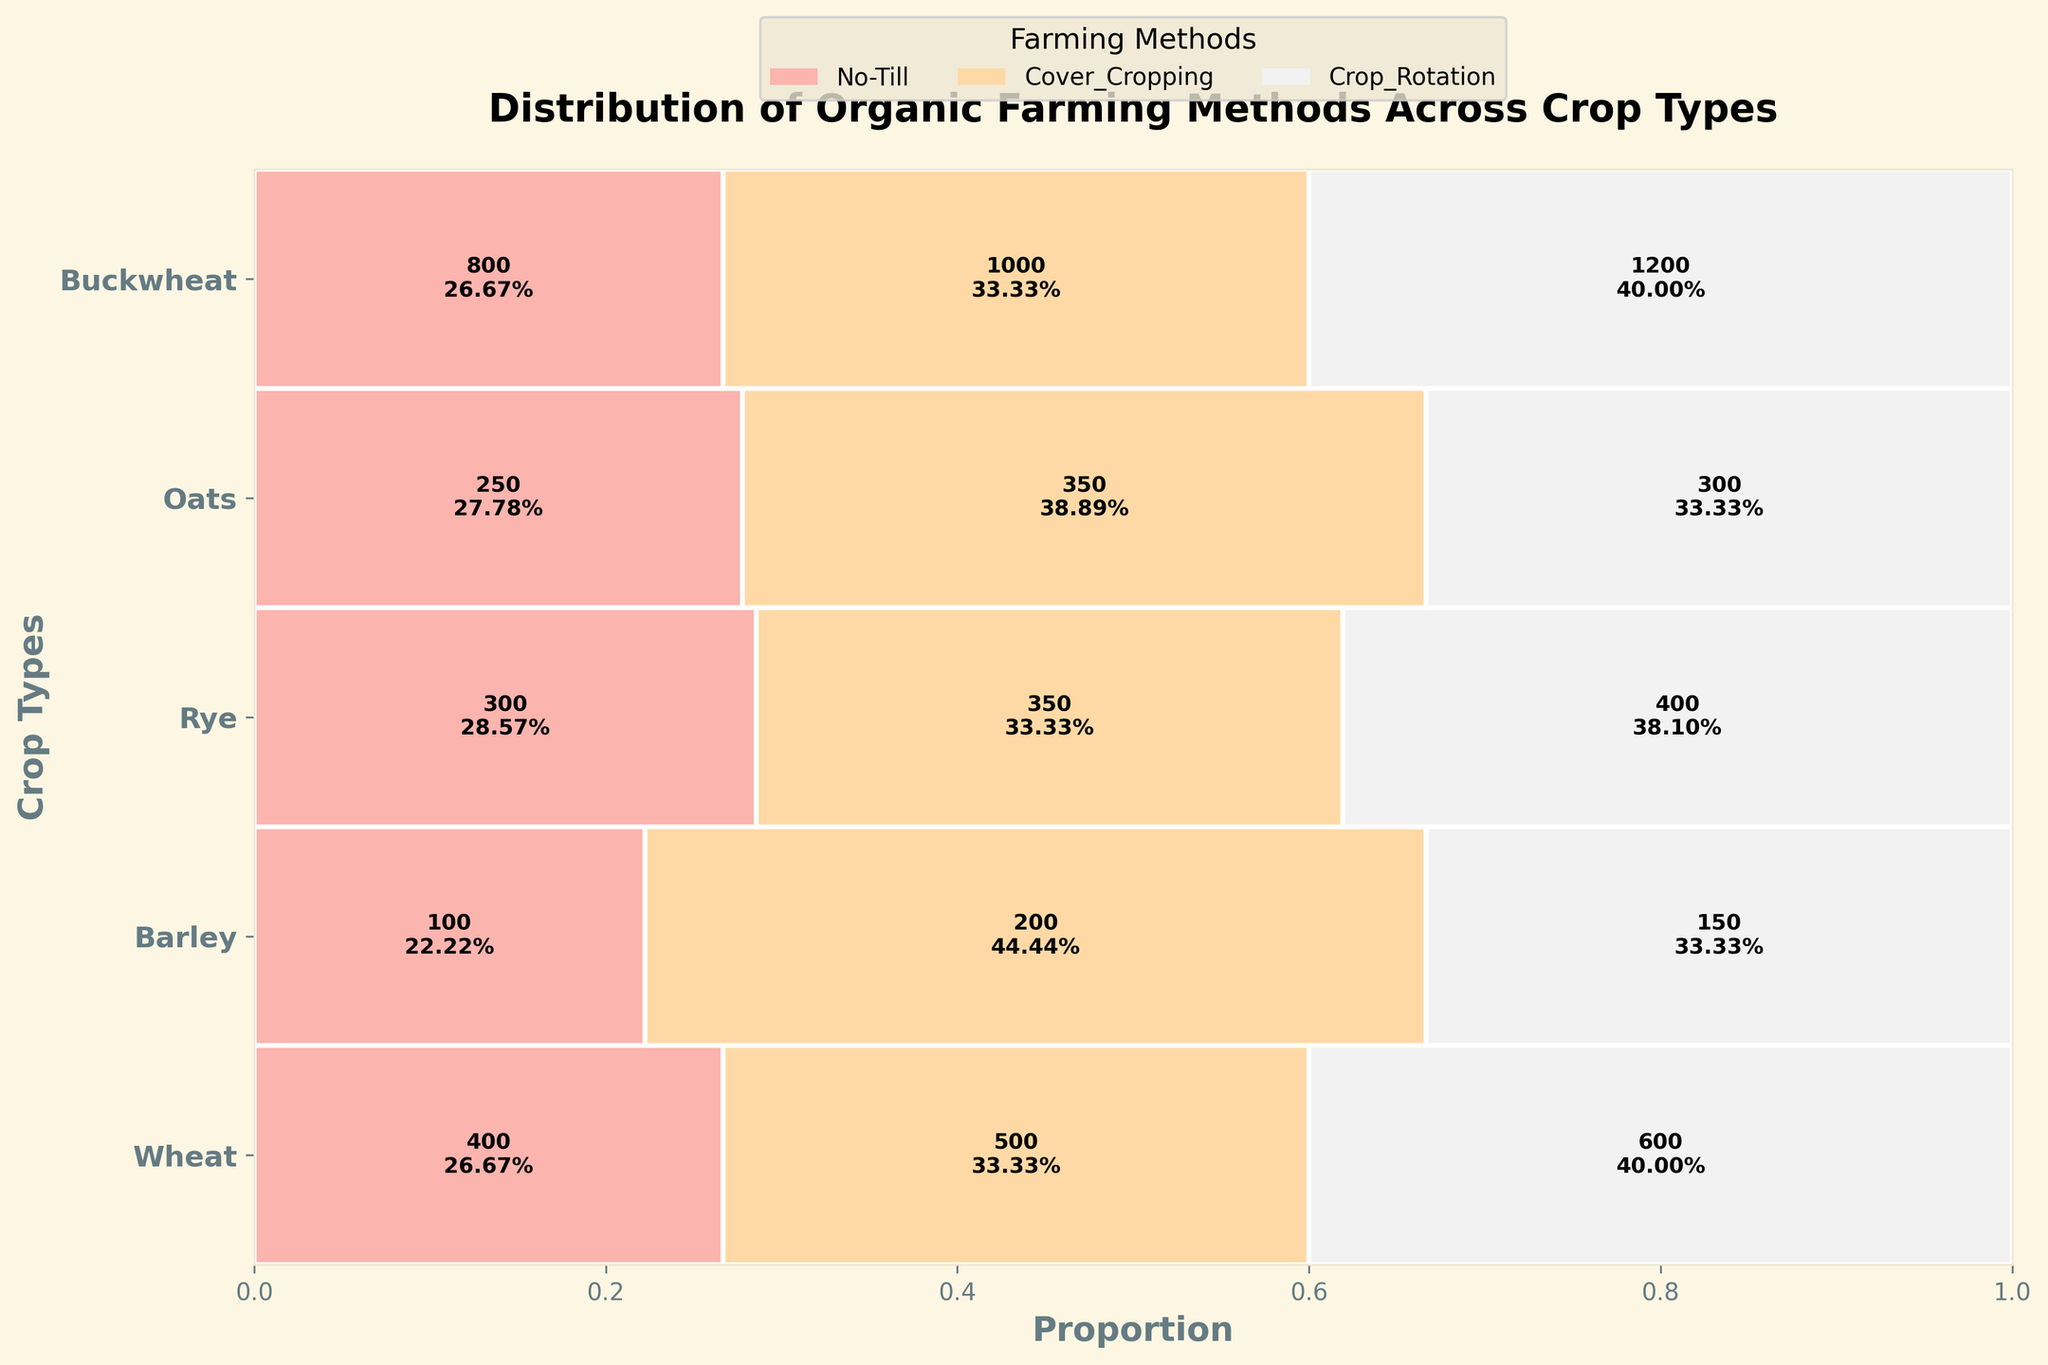What is the title of the plot? The title is located at the top of the plot, it typically describes the content or purpose of the plot.
Answer: Distribution of Organic Farming Methods Across Crop Types Which farming method has the largest acreage for Wheat? From the rectangles representing Wheat, the widest one indicates the farming method with the largest acreage.
Answer: No-Till What is the total acreage for Oats? Sum the numerical values indicated inside the rectangles for Oats.
Answer: 1050 How does acreage of Cover Cropping for Barley compare to Buckwheat? Compare the numerical values found in the Cover Cropping sections for both Barley and Buckwheat.
Answer: Barley has more acreage Which crop type has the smallest acreage for No-Till farming? Identify the crop type associated with the smallest rectangle in the No-Till section.
Answer: Buckwheat What is the proportion (in %) of Crop Rotation methods used for Rye? Locate the Crop Rotation rectangle for Rye and read the percentage value within that rectangle.
Answer: 35% Rank the crop types by total acreage for Cover Cropping from highest to lowest. Compare the numerical Cover Cropping values across all crop types and list them from largest to smallest.
Answer: Wheat, Barley, Oats, Rye, Buckwheat What is the difference in acreage between No-Till and Crop Rotation methods for Barley? Subtract the acreage value of Crop Rotation from the acreage value of No-Till for Barley.
Answer: 100 Which farming method is the least used for Oats in terms of acreage? Identify the smallest rectangle for Oats among the three farming methods.
Answer: Cover Cropping 